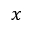<formula> <loc_0><loc_0><loc_500><loc_500>x</formula> 